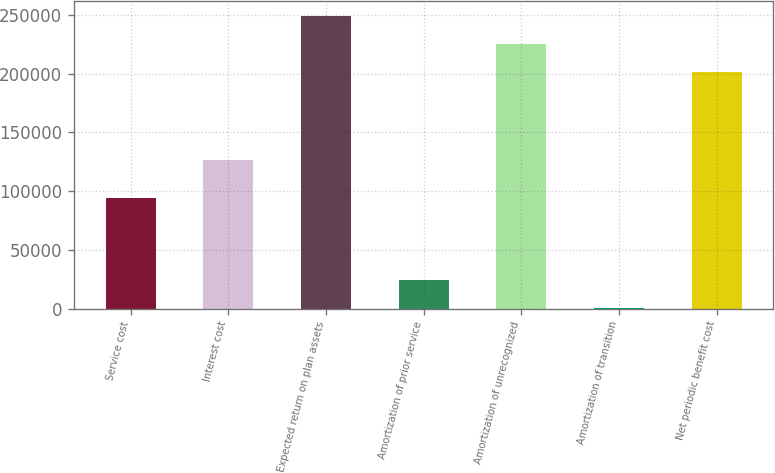Convert chart. <chart><loc_0><loc_0><loc_500><loc_500><bar_chart><fcel>Service cost<fcel>Interest cost<fcel>Expected return on plan assets<fcel>Amortization of prior service<fcel>Amortization of unrecognized<fcel>Amortization of transition<fcel>Net periodic benefit cost<nl><fcel>94356<fcel>126131<fcel>249421<fcel>23969.9<fcel>225469<fcel>18<fcel>201517<nl></chart> 